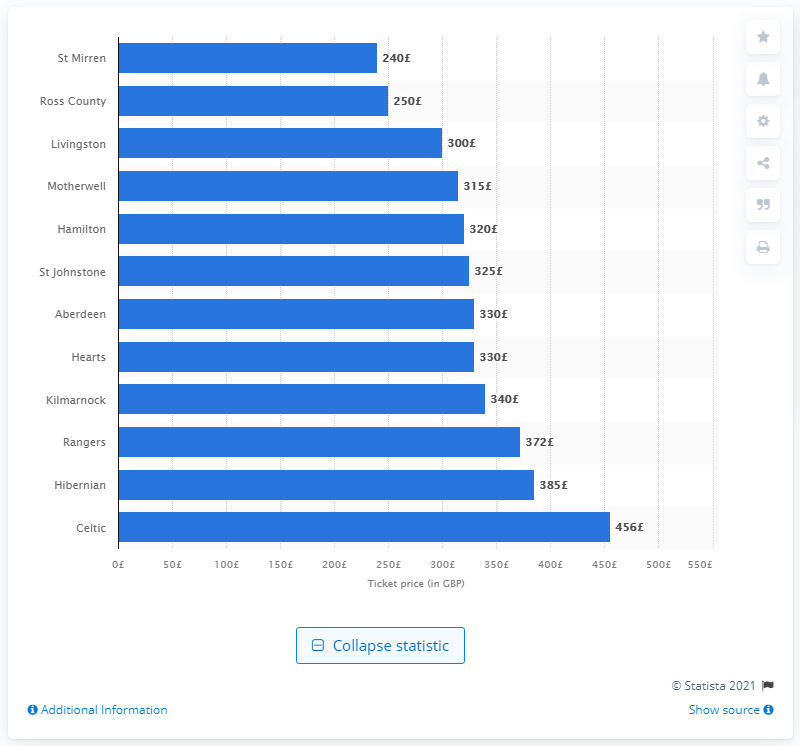List a handful of essential elements in this visual. Ross County was the Scottish Premiership team that sold the cheapest season ticket during the 2019/20 season. 